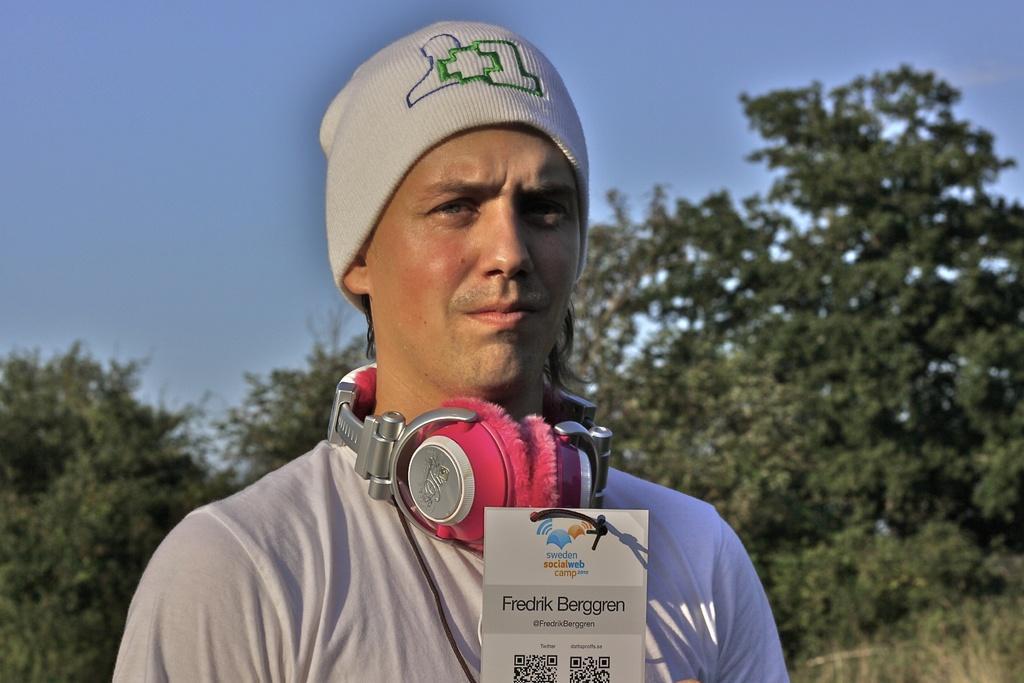In one or two sentences, can you explain what this image depicts? This man wore headset and looking forward. In-front this man there is a card, on this card there are QR codes. Background we can see trees and sky. Sky is in blue color. 